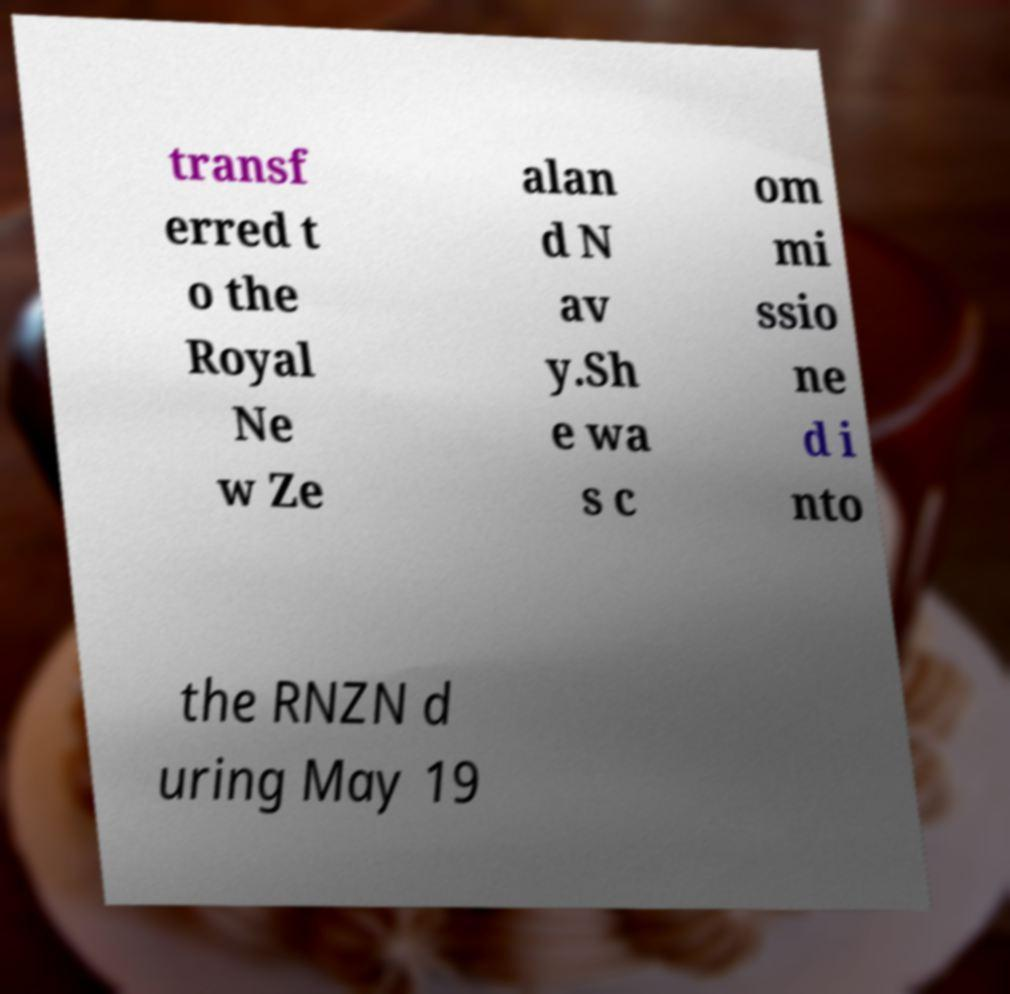There's text embedded in this image that I need extracted. Can you transcribe it verbatim? transf erred t o the Royal Ne w Ze alan d N av y.Sh e wa s c om mi ssio ne d i nto the RNZN d uring May 19 